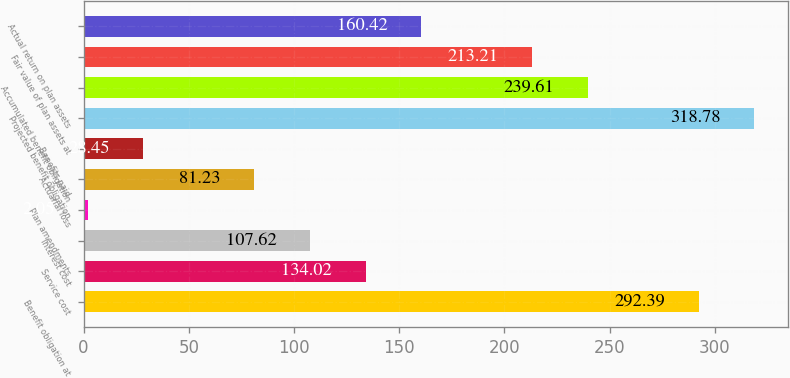Convert chart to OTSL. <chart><loc_0><loc_0><loc_500><loc_500><bar_chart><fcel>Benefit obligation at<fcel>Service cost<fcel>Interest cost<fcel>Plan amendments<fcel>Actuarial loss<fcel>Benefits paid<fcel>Projected benefit obligation<fcel>Accumulated benefit obligation<fcel>Fair value of plan assets at<fcel>Actual return on plan assets<nl><fcel>292.39<fcel>134.02<fcel>107.62<fcel>2.05<fcel>81.23<fcel>28.45<fcel>318.78<fcel>239.61<fcel>213.21<fcel>160.42<nl></chart> 